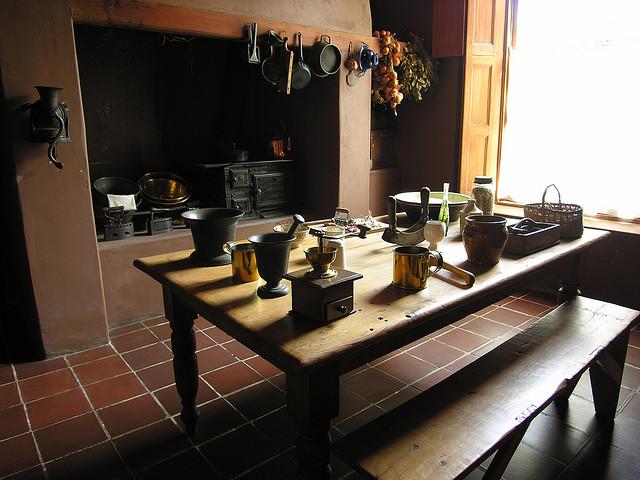Is there a lit fire?
Be succinct. No. What's the floor made of?
Short answer required. Tile. What room is this?
Short answer required. Kitchen. 